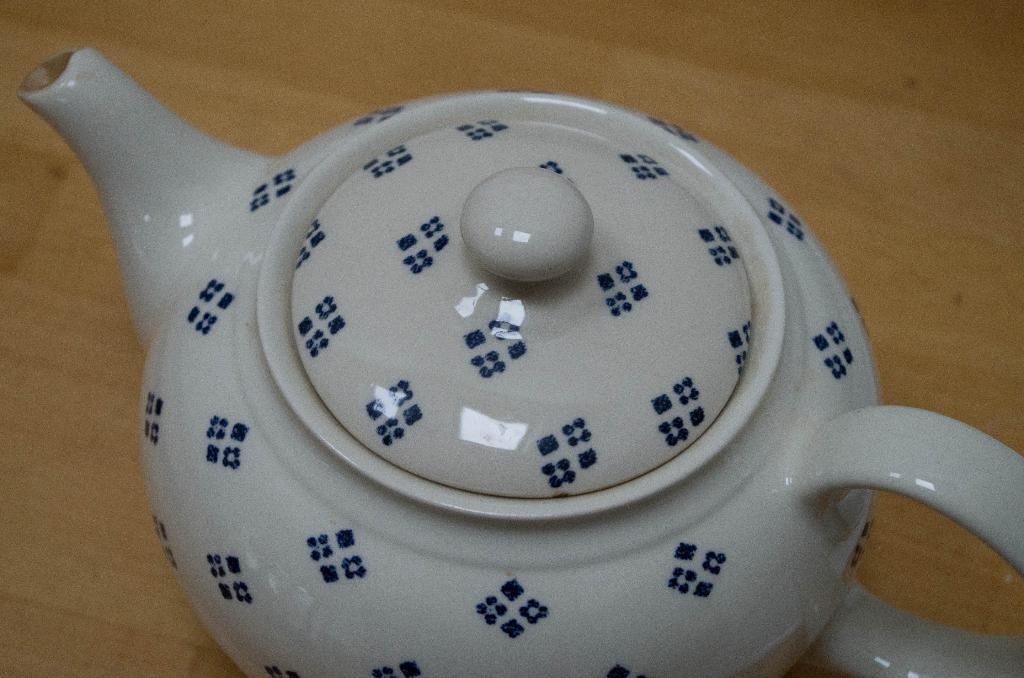What is the color of the teapot in the image? The teapot in the image is white. Where is the teapot located in the image? The teapot is on a wooden table. How many arms are visible on the teapot in the image? There are no arms visible on the teapot in the image, as teapots do not have arms. 